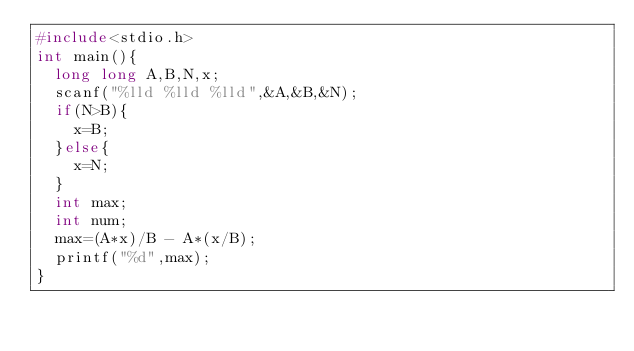Convert code to text. <code><loc_0><loc_0><loc_500><loc_500><_C_>#include<stdio.h>
int main(){
  long long A,B,N,x;
  scanf("%lld %lld %lld",&A,&B,&N);
  if(N>B){
    x=B;
  }else{
    x=N;
  }
  int max;
  int num;
  max=(A*x)/B - A*(x/B);
  printf("%d",max);
}

</code> 